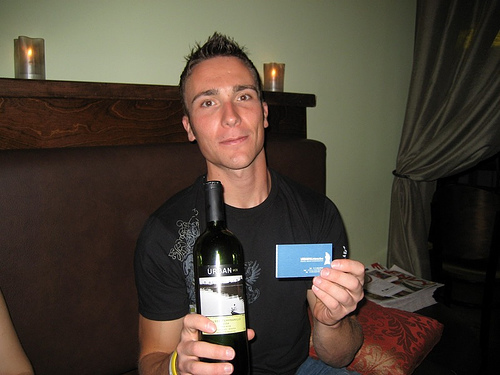<image>What animal is on the bottle? I don't know what animal is on the bottle. It can be deer, elephant, human, cat, bird, bear or none. What animal is on the bottle? I am not sure what animal is on the bottle. It can be seen as a deer, elephant, cat, bird, or bear. 